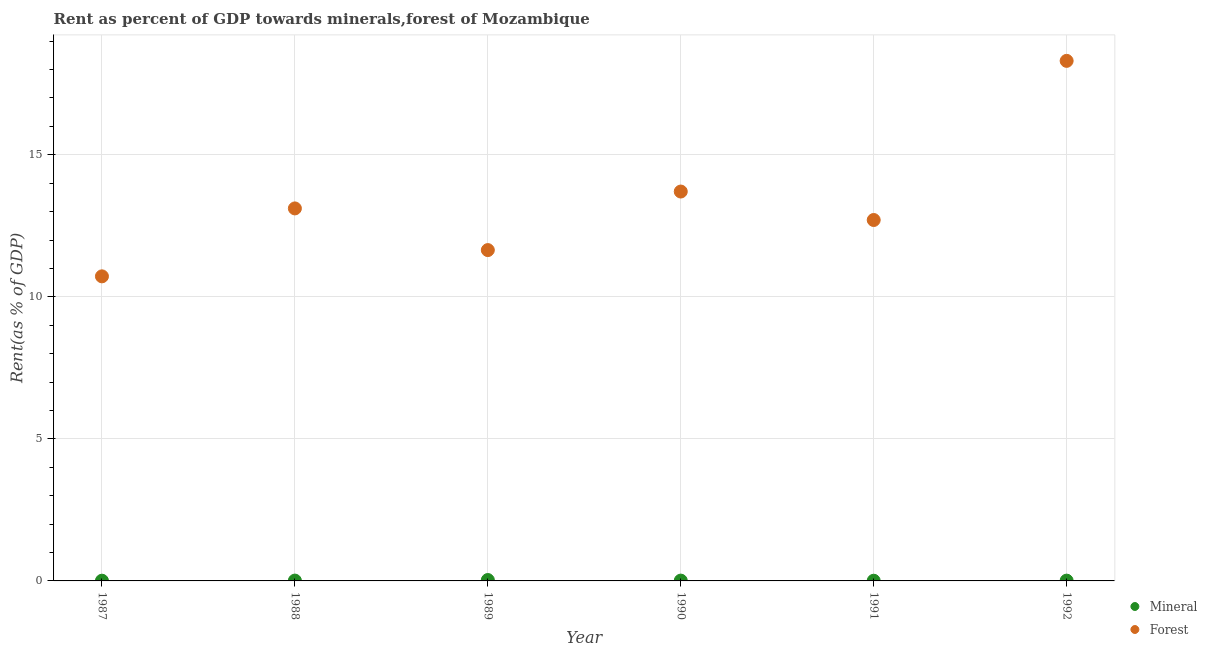How many different coloured dotlines are there?
Give a very brief answer. 2. What is the forest rent in 1990?
Your response must be concise. 13.71. Across all years, what is the maximum forest rent?
Make the answer very short. 18.31. Across all years, what is the minimum forest rent?
Offer a terse response. 10.72. In which year was the forest rent minimum?
Your response must be concise. 1987. What is the total mineral rent in the graph?
Provide a succinct answer. 0.08. What is the difference between the forest rent in 1988 and that in 1991?
Make the answer very short. 0.41. What is the difference between the mineral rent in 1990 and the forest rent in 1988?
Offer a terse response. -13.1. What is the average forest rent per year?
Your response must be concise. 13.37. In the year 1992, what is the difference between the mineral rent and forest rent?
Make the answer very short. -18.3. In how many years, is the mineral rent greater than 2 %?
Your answer should be very brief. 0. What is the ratio of the forest rent in 1988 to that in 1992?
Keep it short and to the point. 0.72. Is the forest rent in 1988 less than that in 1991?
Provide a short and direct response. No. Is the difference between the mineral rent in 1989 and 1990 greater than the difference between the forest rent in 1989 and 1990?
Your answer should be very brief. Yes. What is the difference between the highest and the second highest mineral rent?
Provide a succinct answer. 0.02. What is the difference between the highest and the lowest mineral rent?
Offer a very short reply. 0.02. How many dotlines are there?
Make the answer very short. 2. How many years are there in the graph?
Give a very brief answer. 6. Does the graph contain any zero values?
Provide a succinct answer. No. Where does the legend appear in the graph?
Offer a terse response. Bottom right. What is the title of the graph?
Your answer should be compact. Rent as percent of GDP towards minerals,forest of Mozambique. Does "Foreign liabilities" appear as one of the legend labels in the graph?
Keep it short and to the point. No. What is the label or title of the Y-axis?
Keep it short and to the point. Rent(as % of GDP). What is the Rent(as % of GDP) of Mineral in 1987?
Provide a succinct answer. 0.01. What is the Rent(as % of GDP) in Forest in 1987?
Your answer should be compact. 10.72. What is the Rent(as % of GDP) in Mineral in 1988?
Offer a very short reply. 0.01. What is the Rent(as % of GDP) of Forest in 1988?
Provide a succinct answer. 13.11. What is the Rent(as % of GDP) of Mineral in 1989?
Provide a short and direct response. 0.03. What is the Rent(as % of GDP) of Forest in 1989?
Make the answer very short. 11.65. What is the Rent(as % of GDP) in Mineral in 1990?
Give a very brief answer. 0.01. What is the Rent(as % of GDP) in Forest in 1990?
Ensure brevity in your answer.  13.71. What is the Rent(as % of GDP) of Mineral in 1991?
Ensure brevity in your answer.  0.01. What is the Rent(as % of GDP) in Forest in 1991?
Provide a succinct answer. 12.7. What is the Rent(as % of GDP) in Mineral in 1992?
Your answer should be very brief. 0.01. What is the Rent(as % of GDP) in Forest in 1992?
Provide a short and direct response. 18.31. Across all years, what is the maximum Rent(as % of GDP) in Mineral?
Your answer should be very brief. 0.03. Across all years, what is the maximum Rent(as % of GDP) in Forest?
Make the answer very short. 18.31. Across all years, what is the minimum Rent(as % of GDP) of Mineral?
Offer a very short reply. 0.01. Across all years, what is the minimum Rent(as % of GDP) of Forest?
Ensure brevity in your answer.  10.72. What is the total Rent(as % of GDP) of Mineral in the graph?
Your answer should be very brief. 0.08. What is the total Rent(as % of GDP) in Forest in the graph?
Make the answer very short. 80.19. What is the difference between the Rent(as % of GDP) in Mineral in 1987 and that in 1988?
Make the answer very short. -0. What is the difference between the Rent(as % of GDP) of Forest in 1987 and that in 1988?
Offer a terse response. -2.39. What is the difference between the Rent(as % of GDP) in Mineral in 1987 and that in 1989?
Make the answer very short. -0.02. What is the difference between the Rent(as % of GDP) of Forest in 1987 and that in 1989?
Provide a short and direct response. -0.92. What is the difference between the Rent(as % of GDP) of Mineral in 1987 and that in 1990?
Provide a succinct answer. -0. What is the difference between the Rent(as % of GDP) of Forest in 1987 and that in 1990?
Your answer should be very brief. -2.99. What is the difference between the Rent(as % of GDP) of Mineral in 1987 and that in 1991?
Ensure brevity in your answer.  0. What is the difference between the Rent(as % of GDP) in Forest in 1987 and that in 1991?
Your answer should be very brief. -1.98. What is the difference between the Rent(as % of GDP) of Mineral in 1987 and that in 1992?
Give a very brief answer. -0. What is the difference between the Rent(as % of GDP) in Forest in 1987 and that in 1992?
Offer a very short reply. -7.58. What is the difference between the Rent(as % of GDP) in Mineral in 1988 and that in 1989?
Make the answer very short. -0.02. What is the difference between the Rent(as % of GDP) in Forest in 1988 and that in 1989?
Your response must be concise. 1.47. What is the difference between the Rent(as % of GDP) of Mineral in 1988 and that in 1990?
Offer a very short reply. 0. What is the difference between the Rent(as % of GDP) in Forest in 1988 and that in 1990?
Ensure brevity in your answer.  -0.59. What is the difference between the Rent(as % of GDP) in Mineral in 1988 and that in 1991?
Your answer should be very brief. 0.01. What is the difference between the Rent(as % of GDP) of Forest in 1988 and that in 1991?
Provide a succinct answer. 0.41. What is the difference between the Rent(as % of GDP) in Mineral in 1988 and that in 1992?
Your answer should be compact. 0. What is the difference between the Rent(as % of GDP) of Forest in 1988 and that in 1992?
Offer a terse response. -5.19. What is the difference between the Rent(as % of GDP) of Mineral in 1989 and that in 1990?
Your answer should be very brief. 0.02. What is the difference between the Rent(as % of GDP) of Forest in 1989 and that in 1990?
Provide a succinct answer. -2.06. What is the difference between the Rent(as % of GDP) of Mineral in 1989 and that in 1991?
Your answer should be compact. 0.02. What is the difference between the Rent(as % of GDP) of Forest in 1989 and that in 1991?
Your answer should be very brief. -1.06. What is the difference between the Rent(as % of GDP) in Mineral in 1989 and that in 1992?
Your response must be concise. 0.02. What is the difference between the Rent(as % of GDP) in Forest in 1989 and that in 1992?
Give a very brief answer. -6.66. What is the difference between the Rent(as % of GDP) of Mineral in 1990 and that in 1991?
Make the answer very short. 0. What is the difference between the Rent(as % of GDP) in Mineral in 1990 and that in 1992?
Make the answer very short. 0. What is the difference between the Rent(as % of GDP) of Forest in 1990 and that in 1992?
Offer a very short reply. -4.6. What is the difference between the Rent(as % of GDP) of Mineral in 1991 and that in 1992?
Offer a terse response. -0. What is the difference between the Rent(as % of GDP) of Forest in 1991 and that in 1992?
Your response must be concise. -5.6. What is the difference between the Rent(as % of GDP) in Mineral in 1987 and the Rent(as % of GDP) in Forest in 1988?
Your response must be concise. -13.1. What is the difference between the Rent(as % of GDP) of Mineral in 1987 and the Rent(as % of GDP) of Forest in 1989?
Provide a succinct answer. -11.64. What is the difference between the Rent(as % of GDP) in Mineral in 1987 and the Rent(as % of GDP) in Forest in 1990?
Make the answer very short. -13.7. What is the difference between the Rent(as % of GDP) in Mineral in 1987 and the Rent(as % of GDP) in Forest in 1991?
Ensure brevity in your answer.  -12.7. What is the difference between the Rent(as % of GDP) of Mineral in 1987 and the Rent(as % of GDP) of Forest in 1992?
Make the answer very short. -18.3. What is the difference between the Rent(as % of GDP) of Mineral in 1988 and the Rent(as % of GDP) of Forest in 1989?
Your answer should be compact. -11.63. What is the difference between the Rent(as % of GDP) in Mineral in 1988 and the Rent(as % of GDP) in Forest in 1990?
Give a very brief answer. -13.69. What is the difference between the Rent(as % of GDP) of Mineral in 1988 and the Rent(as % of GDP) of Forest in 1991?
Provide a short and direct response. -12.69. What is the difference between the Rent(as % of GDP) of Mineral in 1988 and the Rent(as % of GDP) of Forest in 1992?
Offer a very short reply. -18.29. What is the difference between the Rent(as % of GDP) in Mineral in 1989 and the Rent(as % of GDP) in Forest in 1990?
Your answer should be very brief. -13.67. What is the difference between the Rent(as % of GDP) in Mineral in 1989 and the Rent(as % of GDP) in Forest in 1991?
Your answer should be compact. -12.67. What is the difference between the Rent(as % of GDP) in Mineral in 1989 and the Rent(as % of GDP) in Forest in 1992?
Offer a terse response. -18.27. What is the difference between the Rent(as % of GDP) in Mineral in 1990 and the Rent(as % of GDP) in Forest in 1991?
Give a very brief answer. -12.69. What is the difference between the Rent(as % of GDP) in Mineral in 1990 and the Rent(as % of GDP) in Forest in 1992?
Give a very brief answer. -18.29. What is the difference between the Rent(as % of GDP) in Mineral in 1991 and the Rent(as % of GDP) in Forest in 1992?
Offer a very short reply. -18.3. What is the average Rent(as % of GDP) of Mineral per year?
Make the answer very short. 0.01. What is the average Rent(as % of GDP) of Forest per year?
Offer a very short reply. 13.37. In the year 1987, what is the difference between the Rent(as % of GDP) of Mineral and Rent(as % of GDP) of Forest?
Keep it short and to the point. -10.71. In the year 1988, what is the difference between the Rent(as % of GDP) of Mineral and Rent(as % of GDP) of Forest?
Offer a terse response. -13.1. In the year 1989, what is the difference between the Rent(as % of GDP) in Mineral and Rent(as % of GDP) in Forest?
Provide a short and direct response. -11.61. In the year 1990, what is the difference between the Rent(as % of GDP) in Mineral and Rent(as % of GDP) in Forest?
Keep it short and to the point. -13.69. In the year 1991, what is the difference between the Rent(as % of GDP) of Mineral and Rent(as % of GDP) of Forest?
Keep it short and to the point. -12.7. In the year 1992, what is the difference between the Rent(as % of GDP) of Mineral and Rent(as % of GDP) of Forest?
Make the answer very short. -18.3. What is the ratio of the Rent(as % of GDP) of Mineral in 1987 to that in 1988?
Your response must be concise. 0.69. What is the ratio of the Rent(as % of GDP) of Forest in 1987 to that in 1988?
Keep it short and to the point. 0.82. What is the ratio of the Rent(as % of GDP) of Mineral in 1987 to that in 1989?
Your answer should be very brief. 0.25. What is the ratio of the Rent(as % of GDP) in Forest in 1987 to that in 1989?
Your answer should be compact. 0.92. What is the ratio of the Rent(as % of GDP) in Mineral in 1987 to that in 1990?
Give a very brief answer. 0.71. What is the ratio of the Rent(as % of GDP) in Forest in 1987 to that in 1990?
Provide a short and direct response. 0.78. What is the ratio of the Rent(as % of GDP) of Mineral in 1987 to that in 1991?
Provide a short and direct response. 1.22. What is the ratio of the Rent(as % of GDP) of Forest in 1987 to that in 1991?
Your answer should be compact. 0.84. What is the ratio of the Rent(as % of GDP) of Mineral in 1987 to that in 1992?
Ensure brevity in your answer.  0.8. What is the ratio of the Rent(as % of GDP) of Forest in 1987 to that in 1992?
Provide a succinct answer. 0.59. What is the ratio of the Rent(as % of GDP) of Mineral in 1988 to that in 1989?
Provide a short and direct response. 0.37. What is the ratio of the Rent(as % of GDP) of Forest in 1988 to that in 1989?
Make the answer very short. 1.13. What is the ratio of the Rent(as % of GDP) in Mineral in 1988 to that in 1990?
Keep it short and to the point. 1.03. What is the ratio of the Rent(as % of GDP) in Forest in 1988 to that in 1990?
Ensure brevity in your answer.  0.96. What is the ratio of the Rent(as % of GDP) in Mineral in 1988 to that in 1991?
Keep it short and to the point. 1.77. What is the ratio of the Rent(as % of GDP) of Forest in 1988 to that in 1991?
Your answer should be compact. 1.03. What is the ratio of the Rent(as % of GDP) in Mineral in 1988 to that in 1992?
Give a very brief answer. 1.17. What is the ratio of the Rent(as % of GDP) of Forest in 1988 to that in 1992?
Your answer should be compact. 0.72. What is the ratio of the Rent(as % of GDP) in Mineral in 1989 to that in 1990?
Ensure brevity in your answer.  2.79. What is the ratio of the Rent(as % of GDP) of Forest in 1989 to that in 1990?
Offer a terse response. 0.85. What is the ratio of the Rent(as % of GDP) in Mineral in 1989 to that in 1991?
Offer a terse response. 4.77. What is the ratio of the Rent(as % of GDP) of Forest in 1989 to that in 1991?
Offer a terse response. 0.92. What is the ratio of the Rent(as % of GDP) in Mineral in 1989 to that in 1992?
Your answer should be compact. 3.16. What is the ratio of the Rent(as % of GDP) in Forest in 1989 to that in 1992?
Your answer should be very brief. 0.64. What is the ratio of the Rent(as % of GDP) of Mineral in 1990 to that in 1991?
Give a very brief answer. 1.71. What is the ratio of the Rent(as % of GDP) in Forest in 1990 to that in 1991?
Offer a very short reply. 1.08. What is the ratio of the Rent(as % of GDP) in Mineral in 1990 to that in 1992?
Keep it short and to the point. 1.13. What is the ratio of the Rent(as % of GDP) of Forest in 1990 to that in 1992?
Provide a short and direct response. 0.75. What is the ratio of the Rent(as % of GDP) in Mineral in 1991 to that in 1992?
Give a very brief answer. 0.66. What is the ratio of the Rent(as % of GDP) in Forest in 1991 to that in 1992?
Give a very brief answer. 0.69. What is the difference between the highest and the second highest Rent(as % of GDP) in Mineral?
Offer a terse response. 0.02. What is the difference between the highest and the second highest Rent(as % of GDP) in Forest?
Give a very brief answer. 4.6. What is the difference between the highest and the lowest Rent(as % of GDP) in Mineral?
Provide a succinct answer. 0.02. What is the difference between the highest and the lowest Rent(as % of GDP) of Forest?
Ensure brevity in your answer.  7.58. 